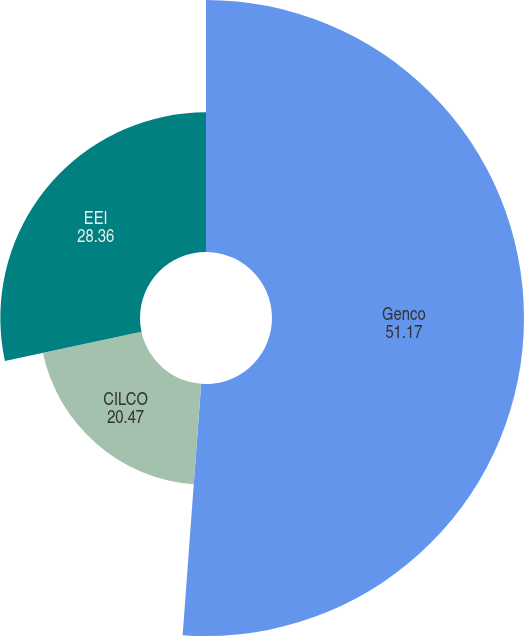<chart> <loc_0><loc_0><loc_500><loc_500><pie_chart><fcel>Genco<fcel>CILCO<fcel>EEI<nl><fcel>51.17%<fcel>20.47%<fcel>28.36%<nl></chart> 